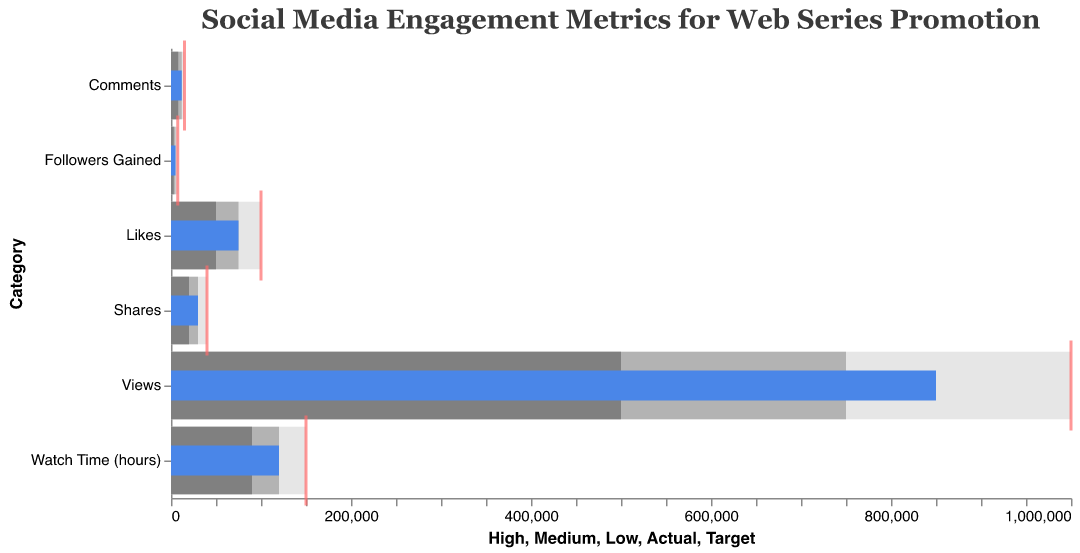what does the color blue represent in the chart? The blue bars in the chart represent the 'Actual' values of social media engagement metrics for the promotional content. These values show how the web series performed in each category.
Answer: Actual values what category's actual value is closest to its target? For this, we need to look at the 'Actual' and 'Target' values for all categories. The actual values for Views, Likes, Comments, Shares, Followers Gained, and Watch Time (hours) are compared to their targets. The 'Actual' value closest to its 'Target' is Shares, with an 'Actual' of 30,000 and a 'Target' of 40,000.
Answer: Shares which category has the highest target value? Checking the target values, we see that Views have a target of 1,000,000, Likes have a target of 100,000, Comments have a target of 15,000, Shares have a target of 40,000, Followers Gained have a target of 7,500, and Watch Time (hours) has a target of 150,000. The highest target value is for Views.
Answer: Views how much higher is the ‘Target’ value than the ‘Actual’ value in the Likes category? The Actual value for Likes is 75,000, and the Target value is 100,000. The difference is 100,000 - 75,000 = 25,000.
Answer: 25,000 which categories have met or exceeded the medium target? All categories should be checked if their 'Actual' values are at least equal to their 'Medium' (target). The categories are Views (850,000 >= 750,000), Likes (75,000 = 75,000), Comments (12,000 = 12,000), Shares (30,000 = 30,000), Followers Gained (5,000 = 5,000), and Watch Time (hours) (120,000 = 120,000). All categories have met or exceeded the medium target.
Answer: All categories what does the gray shading symbolize in the chart? The gray shading areas in the chart represent the different performance benchmarks ('Low', 'Medium', and 'High'). Specifically, the darkest gray is associated with 'Low' performance, the medium gray with 'Medium' performance, and the lightest gray with 'High' performance.
Answer: Performance benchmarks how many categories are represented in the chart? Checking the y-axis, we see there are six distinct categories represented: Views, Likes, Comments, Shares, Followers Gained, and Watch Time (hours).
Answer: 6 in which category is the actual value the furthest below the target value? We need to calculate the difference between Actual and Target for all categories: Views (1,000,000 - 850,000 = 150,000), Likes (100,000 - 75,000 = 25,000), Comments (15,000 - 12,000 = 3,000), Shares (40,000 - 30,000 = 10,000), Followers Gained (7,500 - 5,000 = 2,500), and Watch Time (hours) (150,000 - 120,000 = 30,000). The largest difference is for Views at 150,000.
Answer: Views 